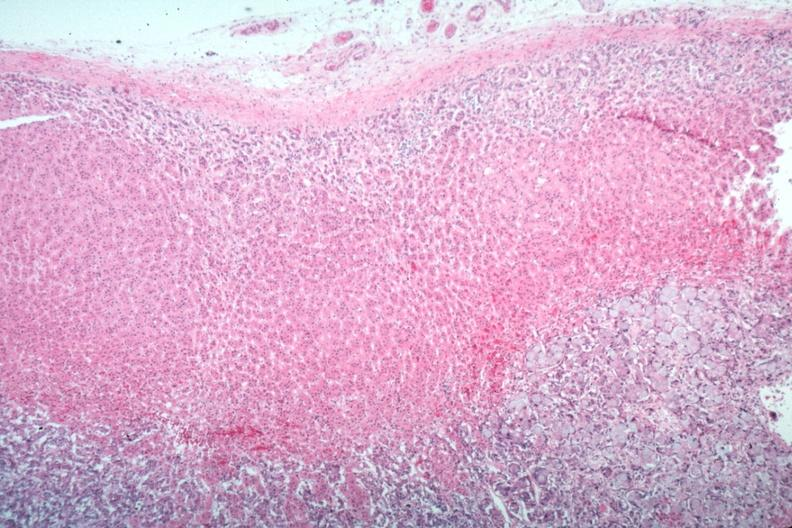s side present?
Answer the question using a single word or phrase. No 